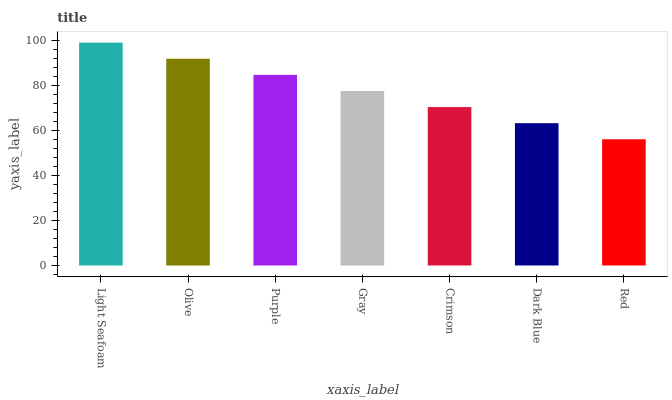Is Red the minimum?
Answer yes or no. Yes. Is Light Seafoam the maximum?
Answer yes or no. Yes. Is Olive the minimum?
Answer yes or no. No. Is Olive the maximum?
Answer yes or no. No. Is Light Seafoam greater than Olive?
Answer yes or no. Yes. Is Olive less than Light Seafoam?
Answer yes or no. Yes. Is Olive greater than Light Seafoam?
Answer yes or no. No. Is Light Seafoam less than Olive?
Answer yes or no. No. Is Gray the high median?
Answer yes or no. Yes. Is Gray the low median?
Answer yes or no. Yes. Is Crimson the high median?
Answer yes or no. No. Is Purple the low median?
Answer yes or no. No. 